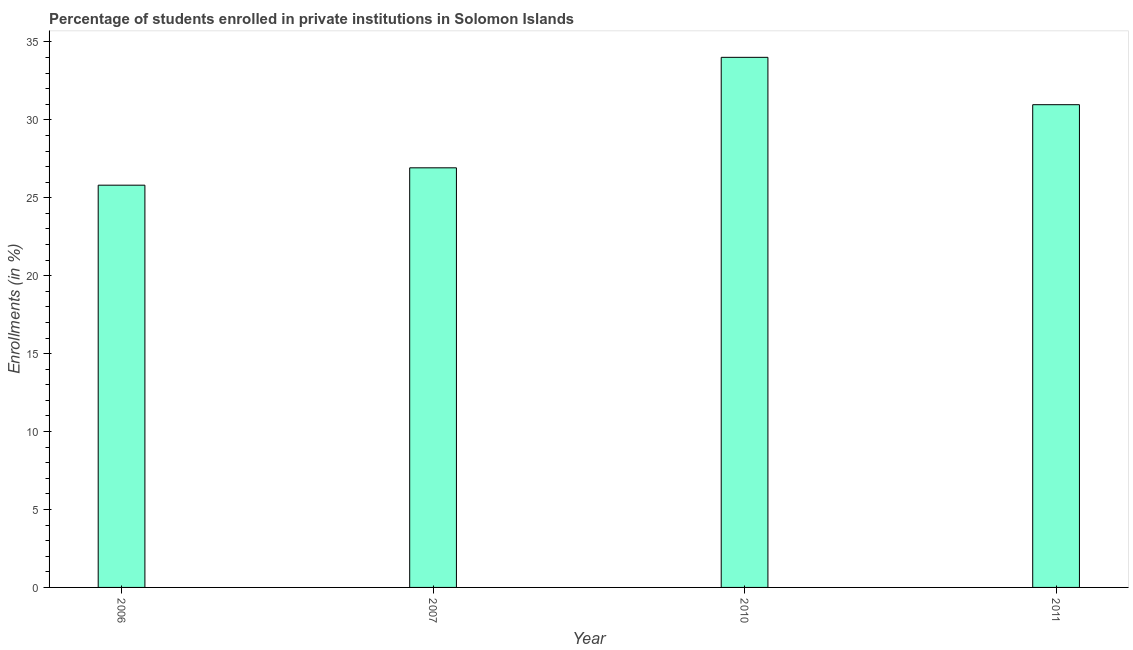Does the graph contain any zero values?
Keep it short and to the point. No. What is the title of the graph?
Provide a short and direct response. Percentage of students enrolled in private institutions in Solomon Islands. What is the label or title of the X-axis?
Offer a very short reply. Year. What is the label or title of the Y-axis?
Provide a succinct answer. Enrollments (in %). What is the enrollments in private institutions in 2006?
Give a very brief answer. 25.81. Across all years, what is the maximum enrollments in private institutions?
Your answer should be compact. 34.01. Across all years, what is the minimum enrollments in private institutions?
Your answer should be very brief. 25.81. What is the sum of the enrollments in private institutions?
Keep it short and to the point. 117.71. What is the difference between the enrollments in private institutions in 2010 and 2011?
Your response must be concise. 3.04. What is the average enrollments in private institutions per year?
Your answer should be compact. 29.43. What is the median enrollments in private institutions?
Your answer should be compact. 28.95. Do a majority of the years between 2011 and 2010 (inclusive) have enrollments in private institutions greater than 9 %?
Your response must be concise. No. What is the difference between the highest and the second highest enrollments in private institutions?
Your answer should be compact. 3.04. Is the sum of the enrollments in private institutions in 2006 and 2010 greater than the maximum enrollments in private institutions across all years?
Offer a very short reply. Yes. In how many years, is the enrollments in private institutions greater than the average enrollments in private institutions taken over all years?
Offer a terse response. 2. What is the difference between two consecutive major ticks on the Y-axis?
Provide a succinct answer. 5. What is the Enrollments (in %) in 2006?
Offer a very short reply. 25.81. What is the Enrollments (in %) in 2007?
Provide a short and direct response. 26.92. What is the Enrollments (in %) in 2010?
Your response must be concise. 34.01. What is the Enrollments (in %) in 2011?
Offer a very short reply. 30.97. What is the difference between the Enrollments (in %) in 2006 and 2007?
Keep it short and to the point. -1.11. What is the difference between the Enrollments (in %) in 2006 and 2010?
Offer a terse response. -8.2. What is the difference between the Enrollments (in %) in 2006 and 2011?
Keep it short and to the point. -5.16. What is the difference between the Enrollments (in %) in 2007 and 2010?
Make the answer very short. -7.09. What is the difference between the Enrollments (in %) in 2007 and 2011?
Your answer should be very brief. -4.05. What is the difference between the Enrollments (in %) in 2010 and 2011?
Give a very brief answer. 3.04. What is the ratio of the Enrollments (in %) in 2006 to that in 2007?
Keep it short and to the point. 0.96. What is the ratio of the Enrollments (in %) in 2006 to that in 2010?
Offer a terse response. 0.76. What is the ratio of the Enrollments (in %) in 2006 to that in 2011?
Your answer should be compact. 0.83. What is the ratio of the Enrollments (in %) in 2007 to that in 2010?
Ensure brevity in your answer.  0.79. What is the ratio of the Enrollments (in %) in 2007 to that in 2011?
Offer a terse response. 0.87. What is the ratio of the Enrollments (in %) in 2010 to that in 2011?
Give a very brief answer. 1.1. 